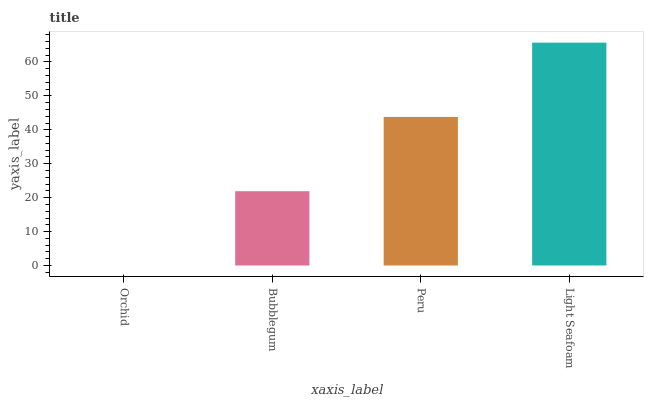Is Orchid the minimum?
Answer yes or no. Yes. Is Light Seafoam the maximum?
Answer yes or no. Yes. Is Bubblegum the minimum?
Answer yes or no. No. Is Bubblegum the maximum?
Answer yes or no. No. Is Bubblegum greater than Orchid?
Answer yes or no. Yes. Is Orchid less than Bubblegum?
Answer yes or no. Yes. Is Orchid greater than Bubblegum?
Answer yes or no. No. Is Bubblegum less than Orchid?
Answer yes or no. No. Is Peru the high median?
Answer yes or no. Yes. Is Bubblegum the low median?
Answer yes or no. Yes. Is Orchid the high median?
Answer yes or no. No. Is Light Seafoam the low median?
Answer yes or no. No. 